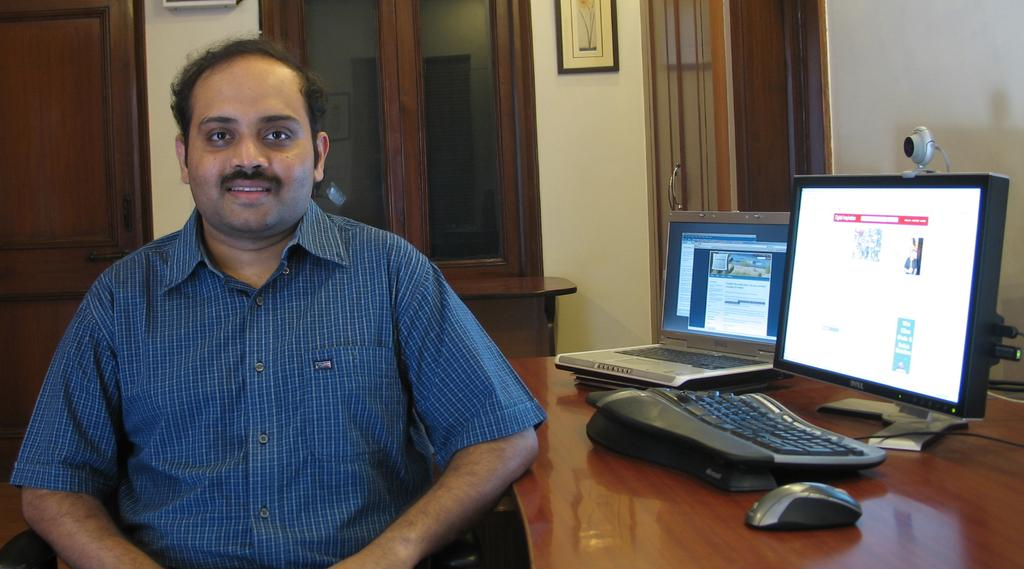What is the person in the image wearing? The person is wearing a blue shirt in the image. What is the person doing in the image? The person is sitting on a table in the image. What is in front of the person? There are monitors in front of the person. What can be seen in the background of the image? There are glass windows and a brown door in the background of the image. Reasoning: Let'g: Let's think step by step in order to produce the conversation. We start by identifying the main subject in the image, which is the person wearing a blue shirt. Then, we describe what the person is doing, which is sitting on a table. Next, we mention the objects in front of the person, which are monitors. Finally, we describe the background of the image, which includes glass windows and a brown door. Absurd Question/Answer: What type of grain can be seen growing in the image? There is no grain visible in the image; it features a person sitting on a table with monitors in front of them. What noise can be heard coming from the brown door in the image? There is no noise present in the image, and the brown door is not associated with any sound. 